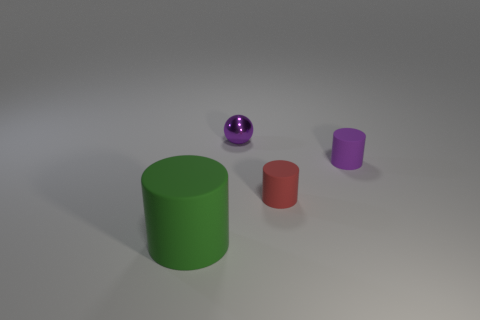Is there any other thing that is the same size as the green object?
Ensure brevity in your answer.  No. The tiny cylinder that is in front of the small rubber cylinder that is to the right of the small cylinder to the left of the purple rubber cylinder is made of what material?
Offer a very short reply. Rubber. Is there any other thing that has the same color as the shiny thing?
Provide a short and direct response. Yes. What number of matte things are to the right of the purple object on the left side of the tiny rubber cylinder on the right side of the tiny red object?
Your answer should be compact. 2. How many cyan objects are small rubber cylinders or tiny matte balls?
Make the answer very short. 0. Do the red rubber cylinder and the purple object that is on the right side of the tiny metal thing have the same size?
Make the answer very short. Yes. What material is the purple object that is the same shape as the red thing?
Your answer should be very brief. Rubber. How many other objects are the same size as the green cylinder?
Provide a short and direct response. 0. What is the shape of the tiny purple object right of the purple thing that is left of the purple thing to the right of the tiny metallic thing?
Give a very brief answer. Cylinder. There is a matte thing that is behind the big thing and in front of the small purple rubber cylinder; what is its shape?
Provide a succinct answer. Cylinder. 